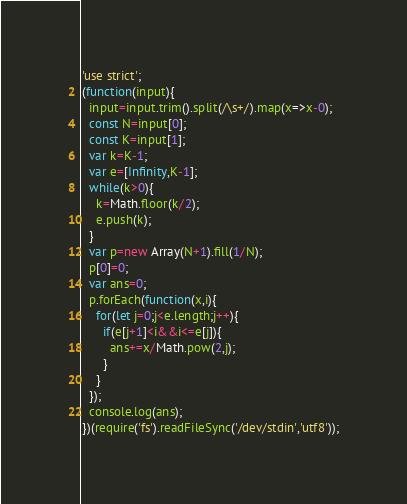Convert code to text. <code><loc_0><loc_0><loc_500><loc_500><_JavaScript_>'use strict';
(function(input){
  input=input.trim().split(/\s+/).map(x=>x-0);
  const N=input[0];
  const K=input[1];
  var k=K-1;
  var e=[Infinity,K-1];
  while(k>0){
    k=Math.floor(k/2);
    e.push(k);
  }
  var p=new Array(N+1).fill(1/N);
  p[0]=0;
  var ans=0;
  p.forEach(function(x,i){
    for(let j=0;j<e.length;j++){
      if(e[j+1]<i&&i<=e[j]){
        ans+=x/Math.pow(2,j);
      }
    }
  });
  console.log(ans);
})(require('fs').readFileSync('/dev/stdin','utf8'));
</code> 